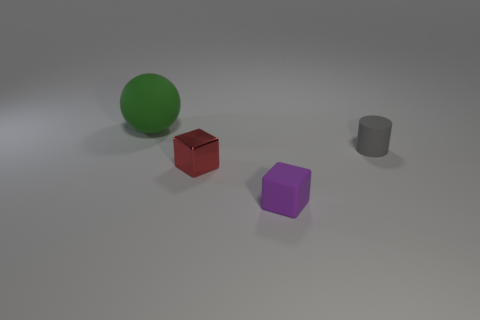Add 1 small cylinders. How many objects exist? 5 Subtract all purple cubes. How many cubes are left? 1 Subtract 1 cubes. How many cubes are left? 1 Subtract 0 purple cylinders. How many objects are left? 4 Subtract all cylinders. How many objects are left? 3 Subtract all yellow cylinders. Subtract all blue balls. How many cylinders are left? 1 Subtract all large objects. Subtract all big green balls. How many objects are left? 2 Add 4 cubes. How many cubes are left? 6 Add 3 purple matte cubes. How many purple matte cubes exist? 4 